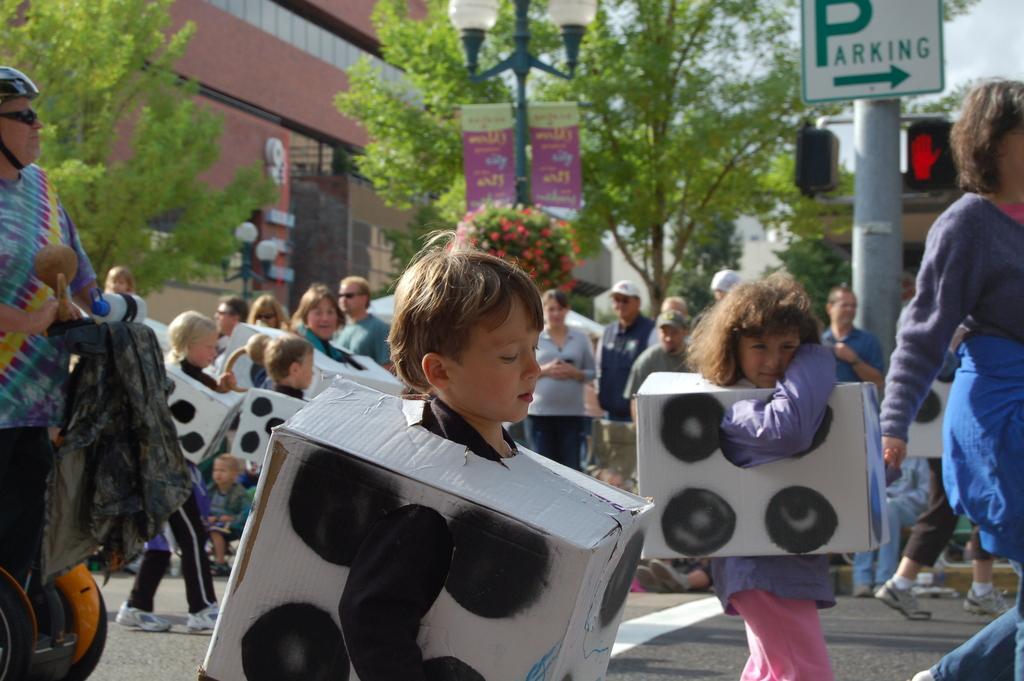How would you summarize this image in a sentence or two? In this image, we can see few kids are wearing carton box costume. Here we can see a group of people are standing. Background we can see trees, pole, sign board, banners, lights, building and sky. 